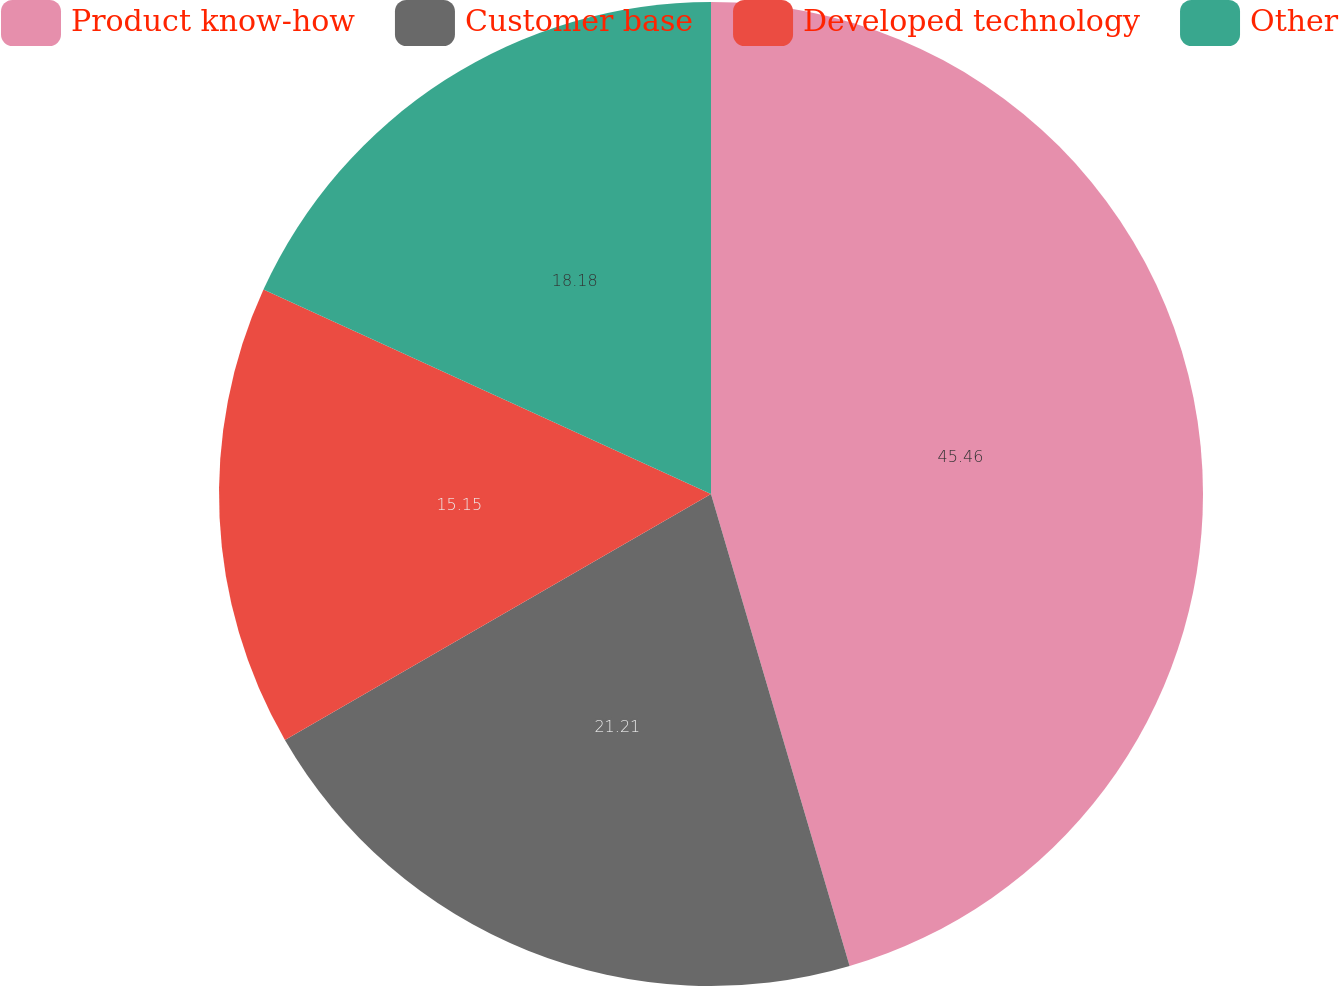Convert chart to OTSL. <chart><loc_0><loc_0><loc_500><loc_500><pie_chart><fcel>Product know-how<fcel>Customer base<fcel>Developed technology<fcel>Other<nl><fcel>45.45%<fcel>21.21%<fcel>15.15%<fcel>18.18%<nl></chart> 